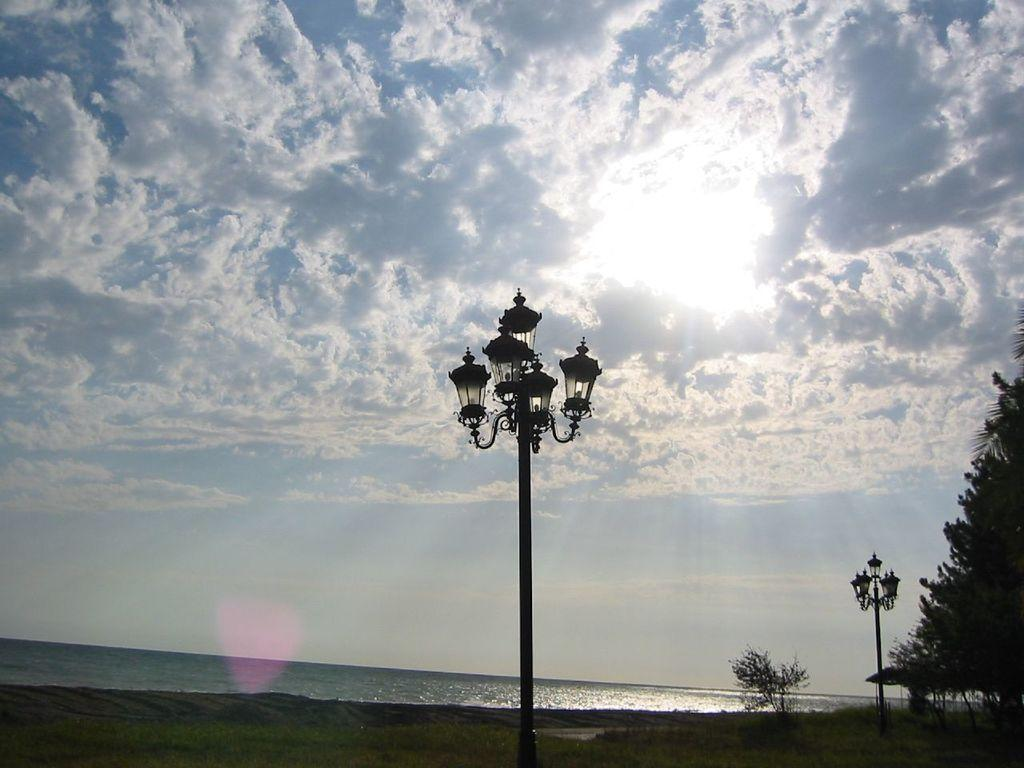What can be seen in the image that provides illumination? There are lights in the image. What type of natural elements are present in the image? There are trees and clouds in the image. What is visible at the bottom of the image? There is water and ground visible at the bottom of the image. Can you describe the man's experience with the whip in the image? There is no man or whip present in the image. 